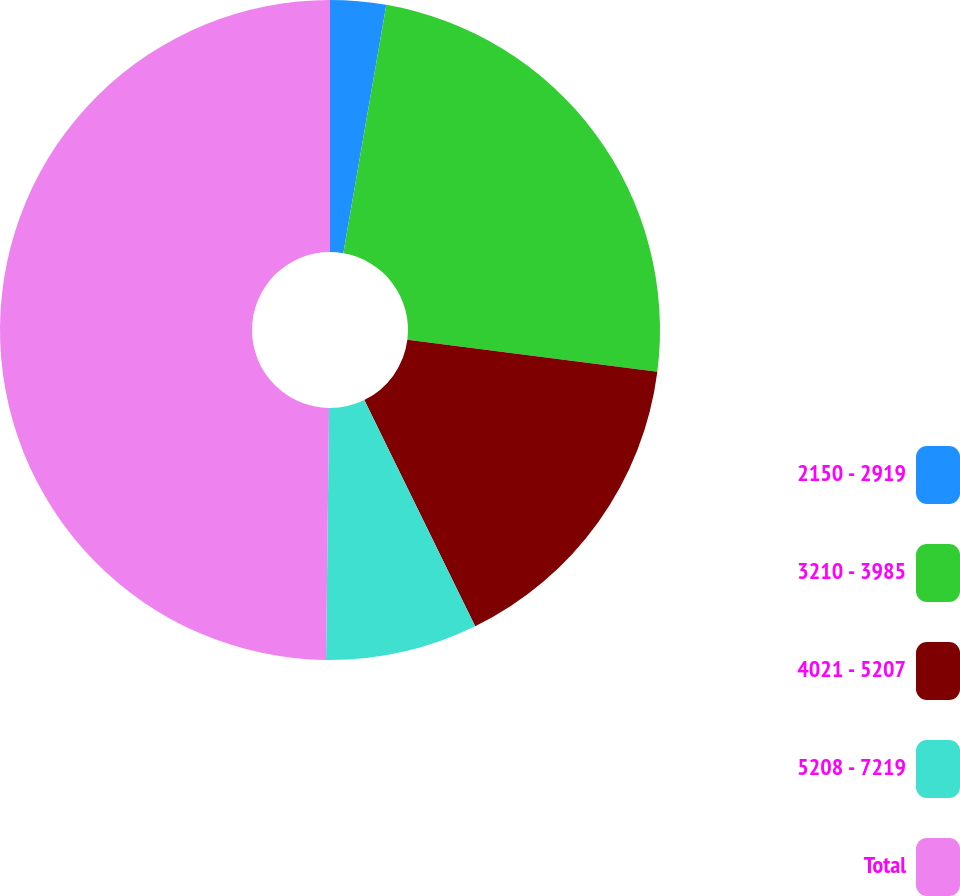Convert chart to OTSL. <chart><loc_0><loc_0><loc_500><loc_500><pie_chart><fcel>2150 - 2919<fcel>3210 - 3985<fcel>4021 - 5207<fcel>5208 - 7219<fcel>Total<nl><fcel>2.73%<fcel>24.29%<fcel>15.73%<fcel>7.44%<fcel>49.81%<nl></chart> 